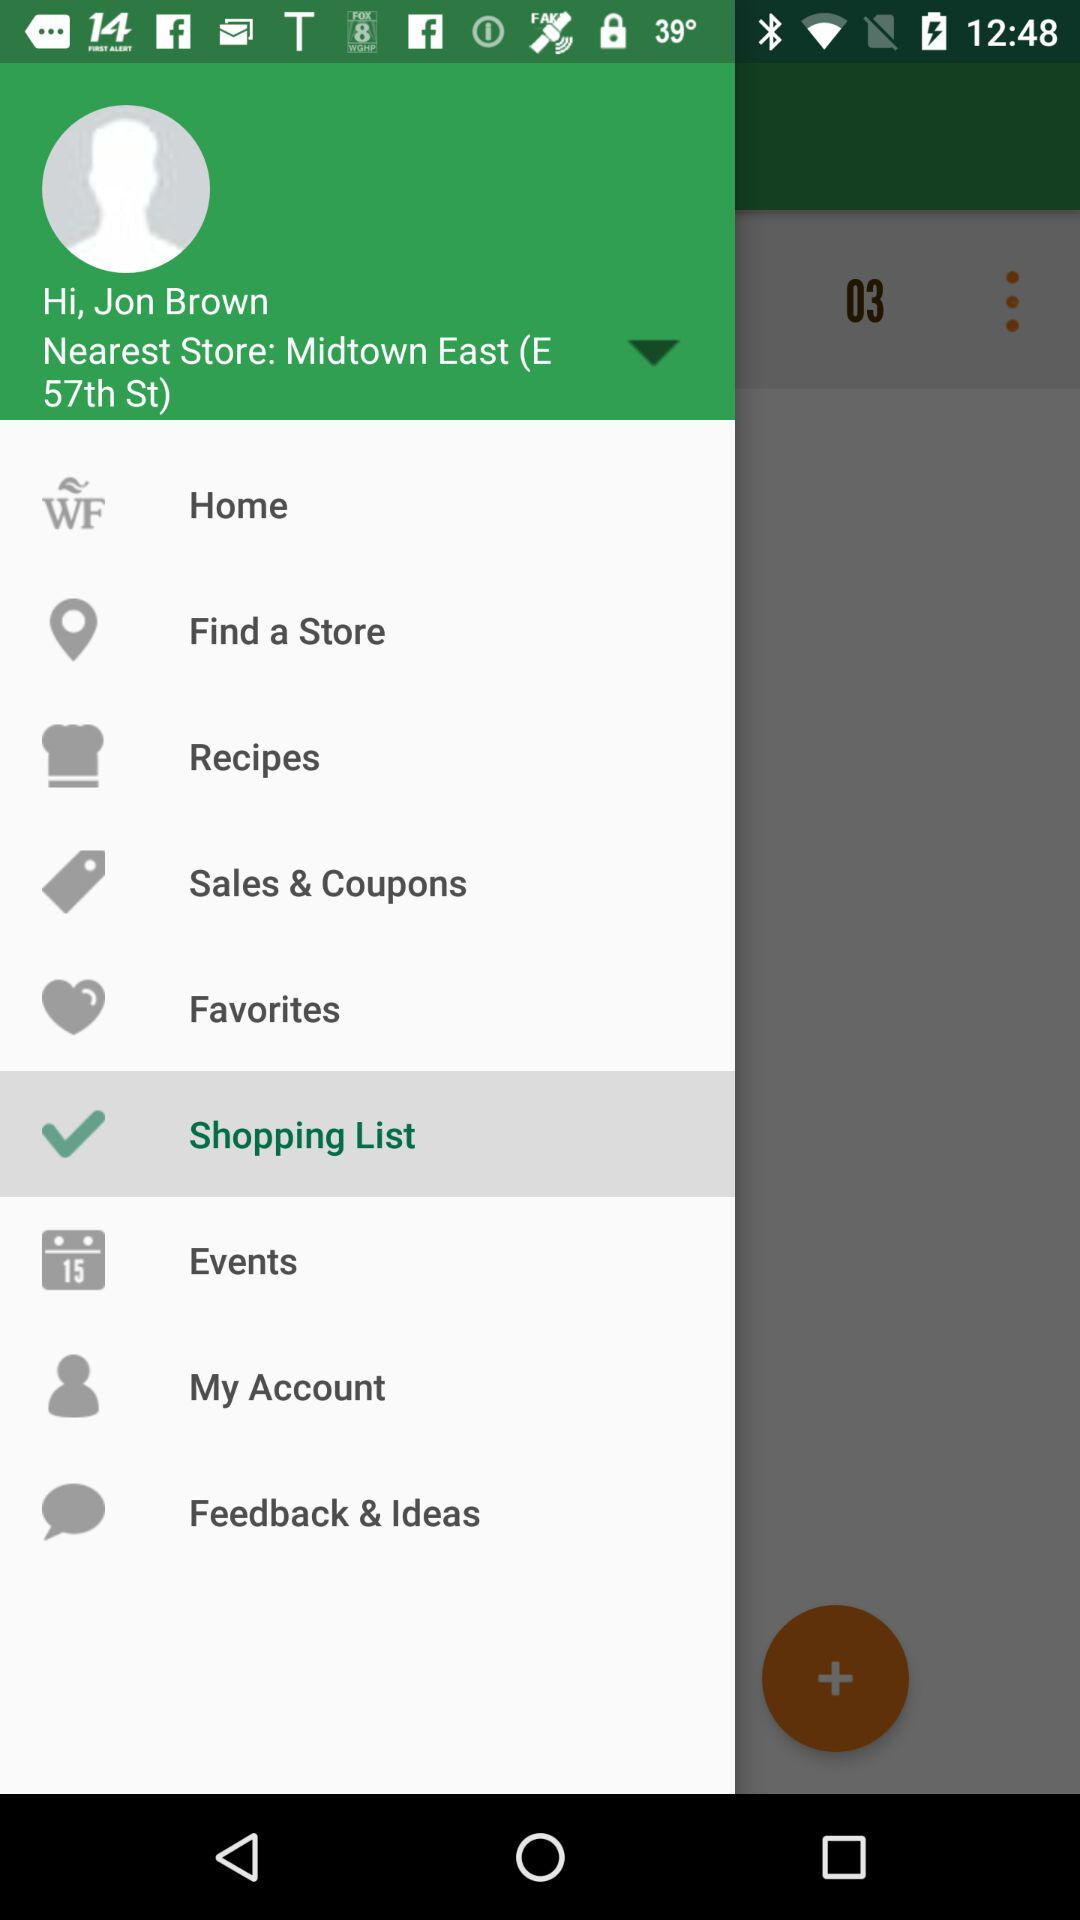What is the name of the user? The name of the user is Jon Brown. 